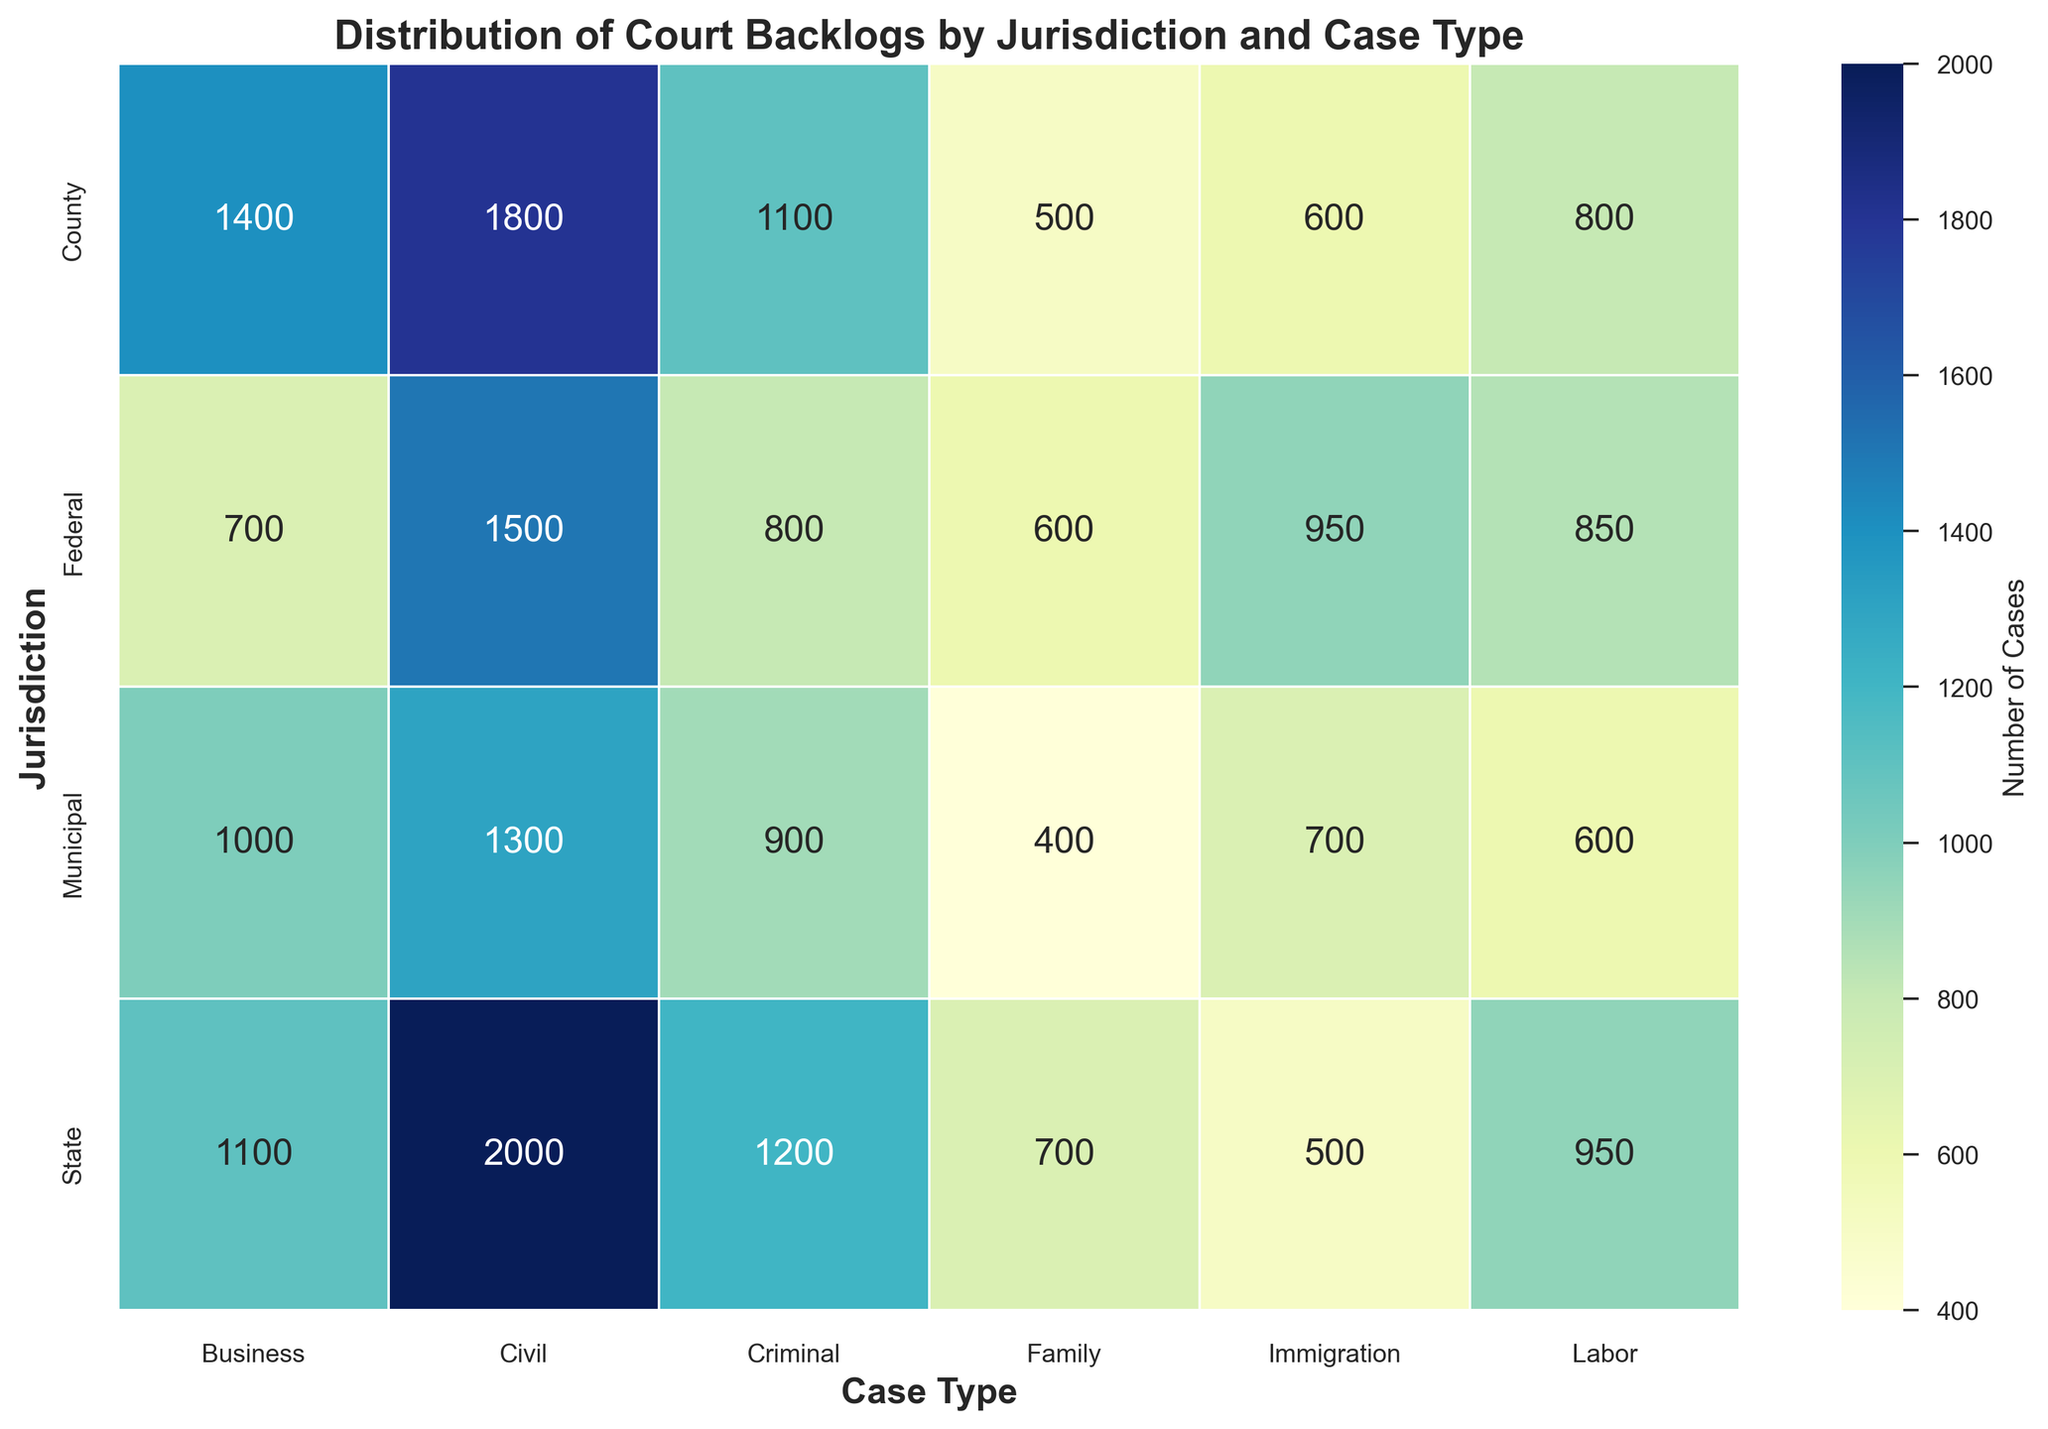What type of case has the highest backlog in the State jurisdiction? Observe the row corresponding to the State jurisdiction and identify the highest value. It is under the Civil column, with 2000 cases.
Answer: Civil Which jurisdiction has the largest backlog for Immigration cases? Look down the Immigration column and compare the numbers for each jurisdiction. The largest number is 950 in the Federal jurisdiction.
Answer: Federal Compare the backlogs for Criminal cases in Municipal and Federal jurisdictions. Which is higher, and by how much? Observe the Criminal column and note the values for Municipal (900) and Federal (800). Subtract 800 from 900.
Answer: Municipal by 100 What is the total backlog of Family cases across all jurisdictions? Sum the values in the Family column: 600 (Federal) + 700 (State) + 500 (County) + 400 (Municipal) = 2200.
Answer: 2200 Which has a greater backlog in the Municipal jurisdiction: Labor cases or Business cases, and by how much? Compare the values for Labor (600) and Business (1000) in the Municipal row. Subtract 600 from 1000.
Answer: Business by 400 In which jurisdiction is the backlog of Civil cases the second highest? Rank the Civil backlogs: State (2000), County (1800), Federal (1500), Municipal (1300). The second highest is County with 1800.
Answer: County What is the average backlog of Labor cases across all jurisdictions? Calculate the mean of the Labor column: (850 + 950 + 800 + 600) / 4 = 800.
Answer: 800 Which jurisdiction has the most evenly distributed backlog across all case types? Look at each row to see which has the least variation between its minimum and maximum backlog values. Municipal has the least variation (400 to 1300).
Answer: Municipal Compare the Civil backlog between State and County jurisdictions. Which has fewer cases and by how many? Look at the Civil column: State (2000) and County (1800). Subtract 1800 from 2000.
Answer: County by 200 What is the total backlog for Business cases across all jurisdictions? Sum the values in the Business column: 700 (Federal) + 1100 (State) + 1400 (County) + 1000 (Municipal) = 4200.
Answer: 4200 